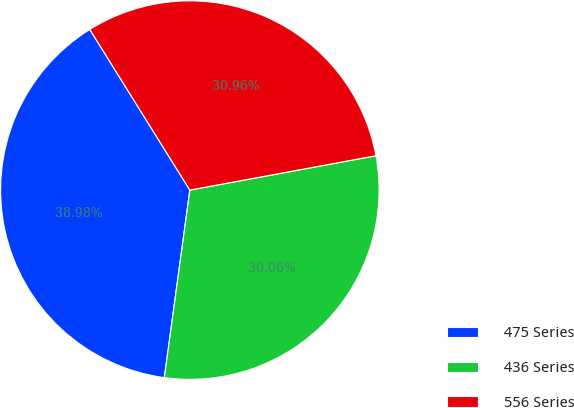<chart> <loc_0><loc_0><loc_500><loc_500><pie_chart><fcel>475 Series<fcel>436 Series<fcel>556 Series<nl><fcel>38.98%<fcel>30.06%<fcel>30.96%<nl></chart> 